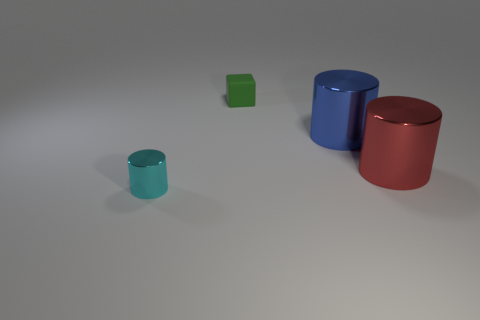Are there the same number of tiny cylinders that are on the left side of the large red cylinder and gray shiny cylinders? no 